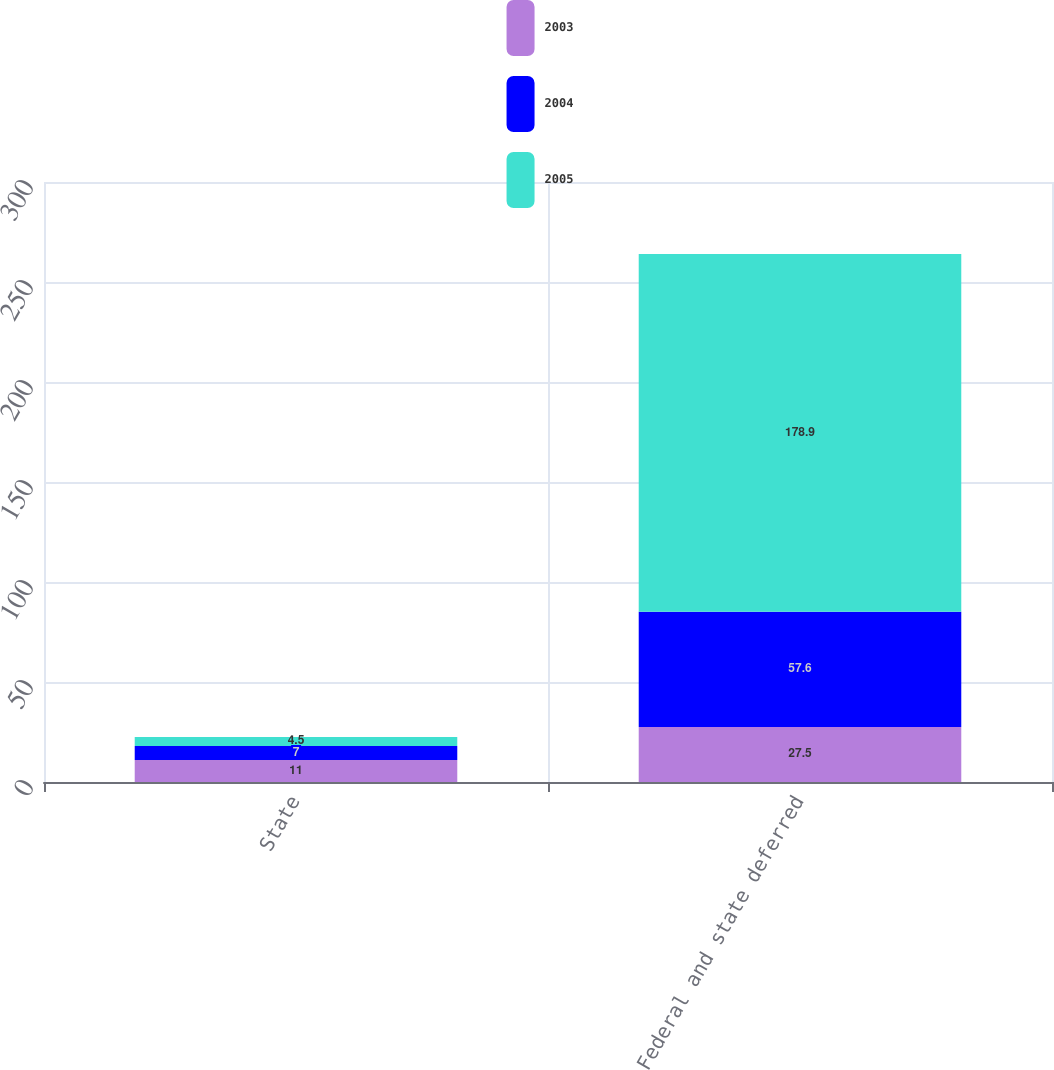Convert chart to OTSL. <chart><loc_0><loc_0><loc_500><loc_500><stacked_bar_chart><ecel><fcel>State<fcel>Federal and state deferred<nl><fcel>2003<fcel>11<fcel>27.5<nl><fcel>2004<fcel>7<fcel>57.6<nl><fcel>2005<fcel>4.5<fcel>178.9<nl></chart> 